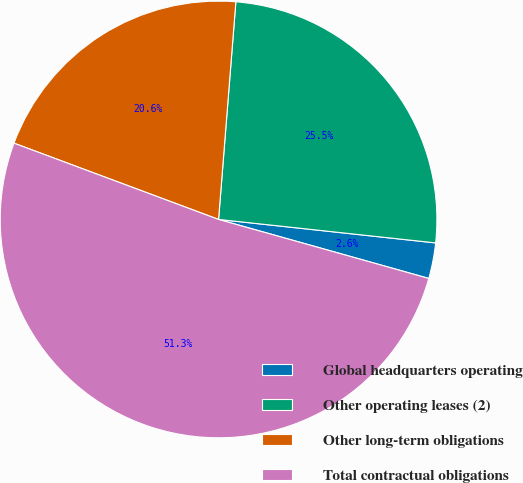<chart> <loc_0><loc_0><loc_500><loc_500><pie_chart><fcel>Global headquarters operating<fcel>Other operating leases (2)<fcel>Other long-term obligations<fcel>Total contractual obligations<nl><fcel>2.64%<fcel>25.45%<fcel>20.58%<fcel>51.32%<nl></chart> 